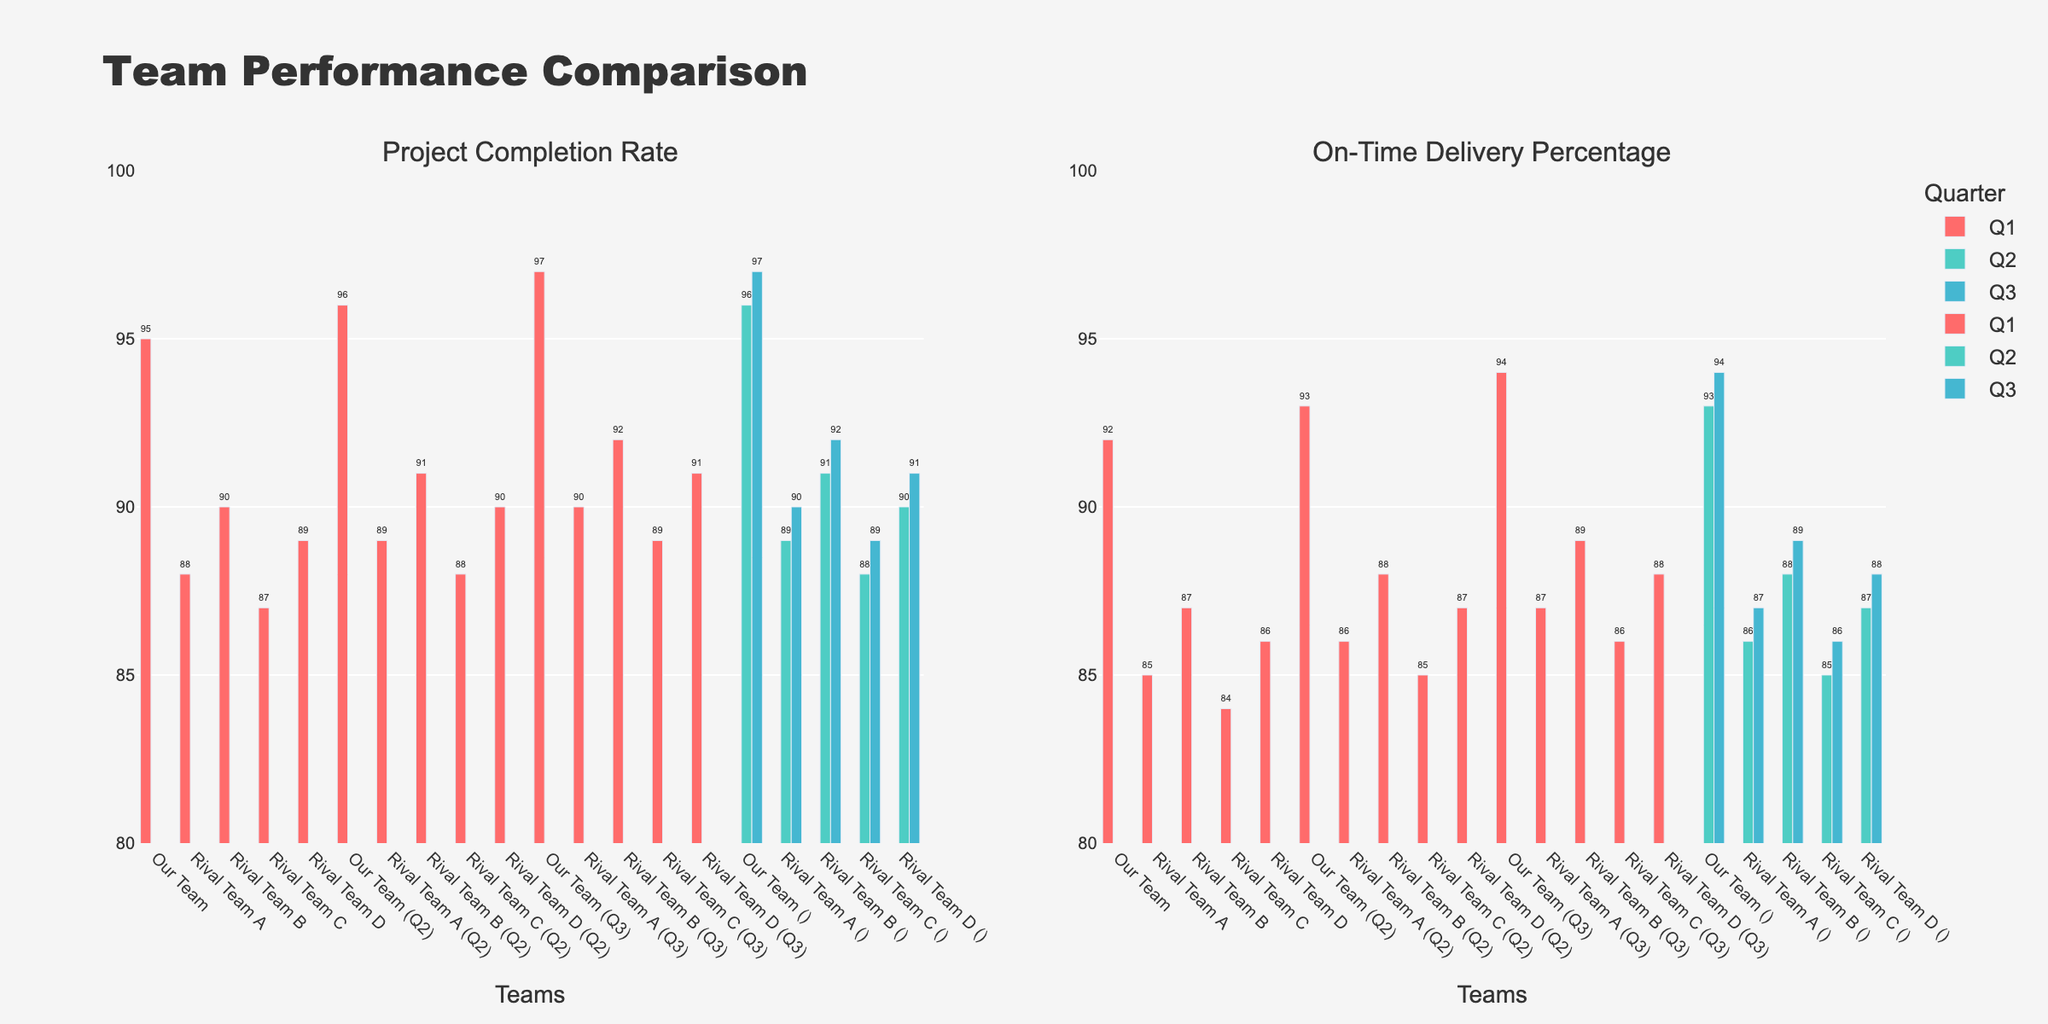Which team has the highest Project Completion Rate in Q3? Reviewing the bar graph for Project Completion Rate and focusing on Q3, we observe that "Our Team" has the highest Project Completion Rate bar compared to other teams.
Answer: Our Team Which team has the lowest On-Time Delivery Percentage in Q2? Considering the On-Time Delivery Percentage bars for Q2, "Rival Team C" shows the shortest bar, indicating the lowest percentage.
Answer: Rival Team C What is the total Project Completion Rate for "Our Team" across all quarters? By summing up the Project Completion Rate for "Our Team" across Q1 (95), Q2 (96), and Q3 (97), we get 95 + 96 + 97 = 288.
Answer: 288 Comparing Q1 and Q3, which quarter shows a higher On-Time Delivery Percentage for "Rival Team B" and by how much? For "Rival Team B," the Q1 On-Time Delivery Percentage is 87%, and for Q3, it is 89%. The difference is 89 - 87 = 2%.
Answer: Q3 by 2% Which team shows the most improvement in Project Completion Rate from Q1 to Q3? By examining the increase in Project Completion Rate from Q1 to Q3 for each team, "Our Team" improved from 95% in Q1 to 97% in Q3, which is a rise of 2%. No other team shows a greater increase.
Answer: Our Team How does the average Project Completion Rate of "Rival Team D" across all quarters compare to "Rival Team A"? Calculating the average for "Rival Team D": (89 + 90 + 91) / 3 = 270 / 3 = 90. For "Rival Team A": (88 + 89 + 90) / 3 = 267 / 3 = 89. They are compared to see which is higher.
Answer: Rival Team D by 1% What is the absolute difference in On-Time Delivery Percentage between "Our Team" and "Rival Team A" in Q1? Subtracting the On-Time Delivery Percentage of "Rival Team A" from "Our Team" for Q1: 92 - 85 = 7.
Answer: 7 Which team shows a consistent increase in Project Completion Rate across all quarters? Analyzing the bars for Project Completion Rate across all quarters, "Our Team" shows an increasing trend: 95 (Q1), 96 (Q2), 97 (Q3).
Answer: Our Team Is there any team that has the same On-Time Delivery Percentage in Q2 and Q3, and if so, which team? By looking at the bars for On-Time Delivery Percentage, "Rival Team C" maintains 85% in both Q2 and Q3.
Answer: Rival Team C 